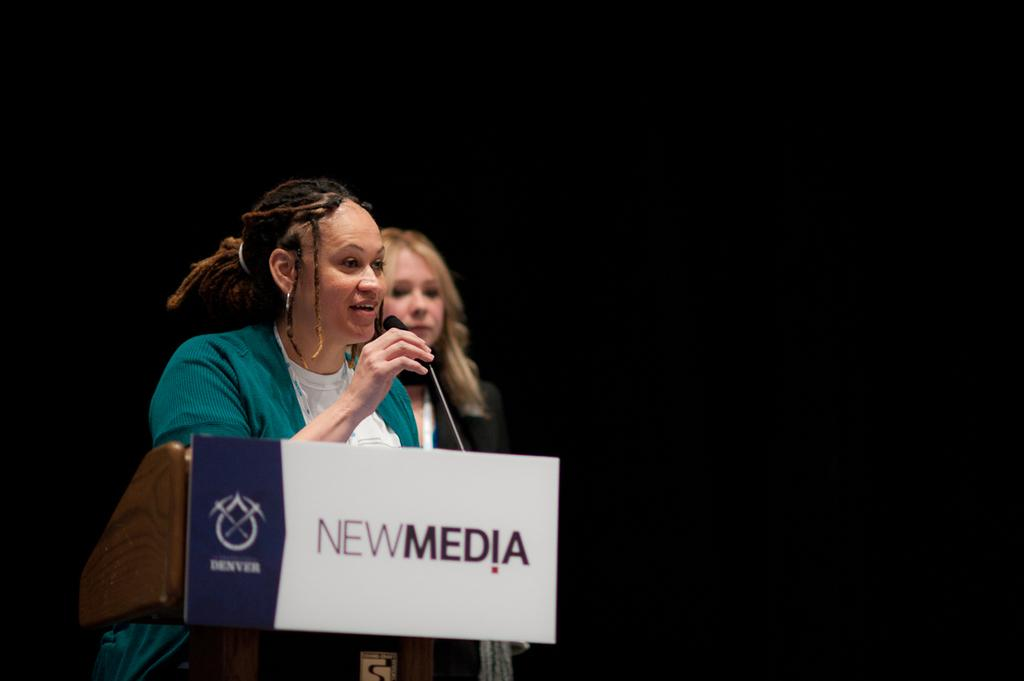What is the woman in the image holding? The woman is holding a microphone. What is in front of the woman? There is a board on a podium in front of the woman. Can you describe the position of the second woman in the image? The second woman is standing behind the first woman. What can be observed about the background in the image? The background is dark. How many things can be seen on the floor in the image? There is no information about any objects on the floor in the image, so it is impossible to determine the number of things present. 